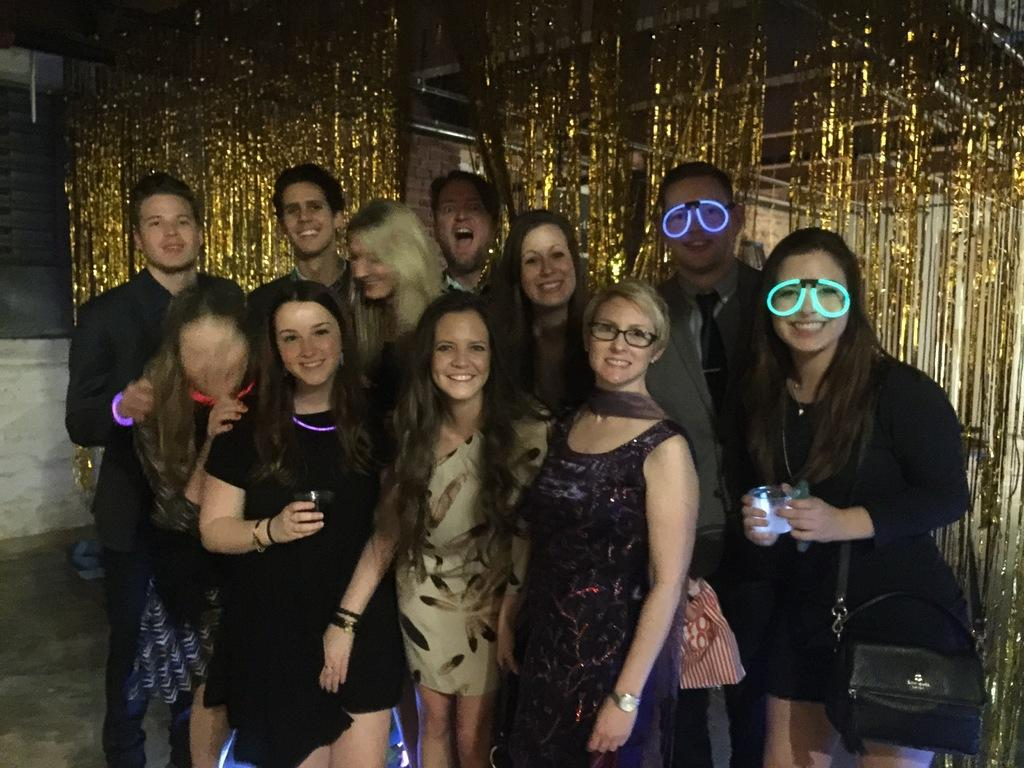Who or what is present in the image? There are people in the image. What are the people doing in the image? The people are smiling. What can be seen in the background of the image? There are decorative items and a wall visible in the background of the image. What type of train can be seen in the background of the image? There is no train present in the image; the background features decorative items and a wall. 